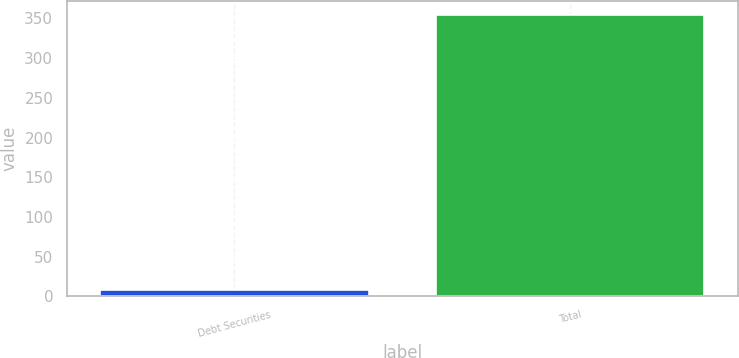Convert chart. <chart><loc_0><loc_0><loc_500><loc_500><bar_chart><fcel>Debt Securities<fcel>Total<nl><fcel>8<fcel>354.6<nl></chart> 